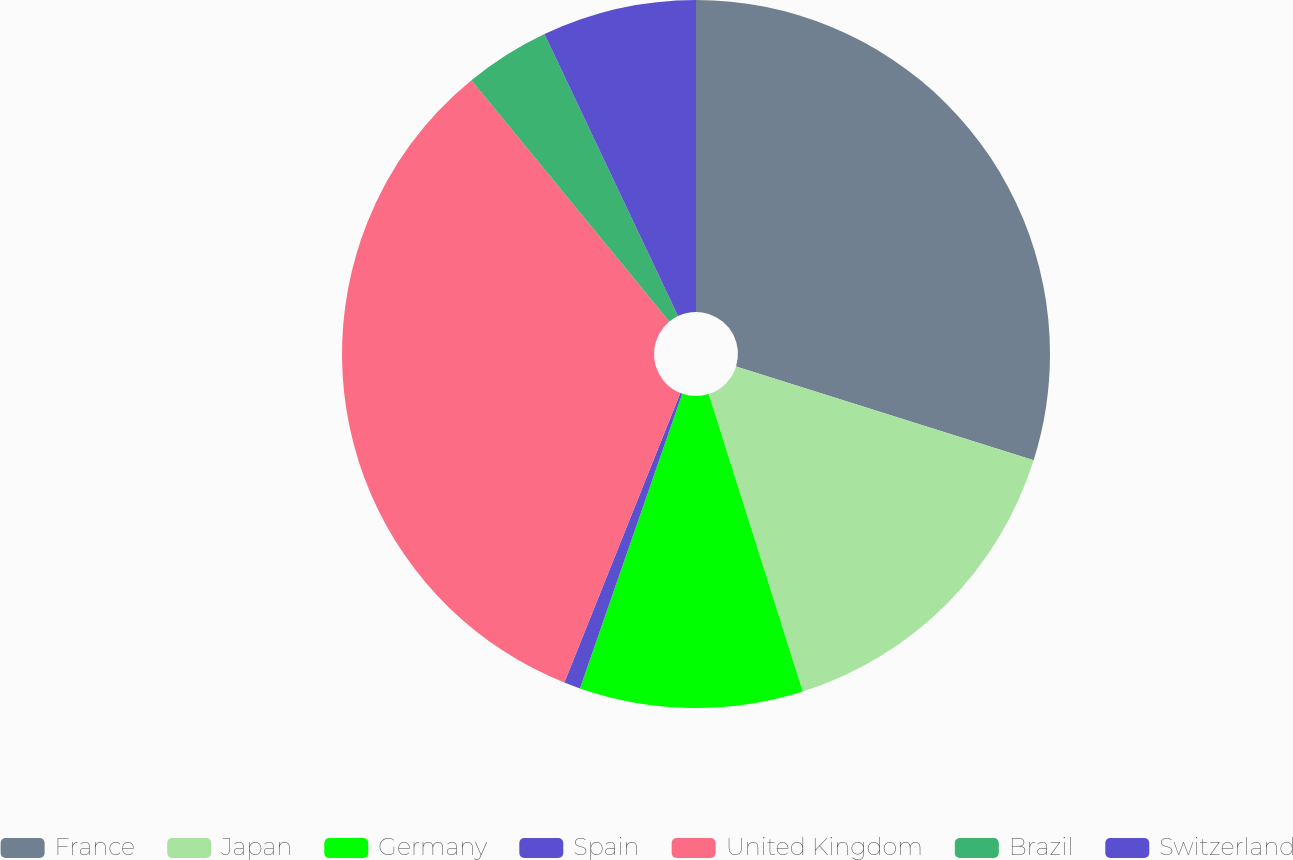Convert chart. <chart><loc_0><loc_0><loc_500><loc_500><pie_chart><fcel>France<fcel>Japan<fcel>Germany<fcel>Spain<fcel>United Kingdom<fcel>Brazil<fcel>Switzerland<nl><fcel>29.86%<fcel>15.27%<fcel>10.19%<fcel>0.75%<fcel>33.0%<fcel>3.9%<fcel>7.04%<nl></chart> 